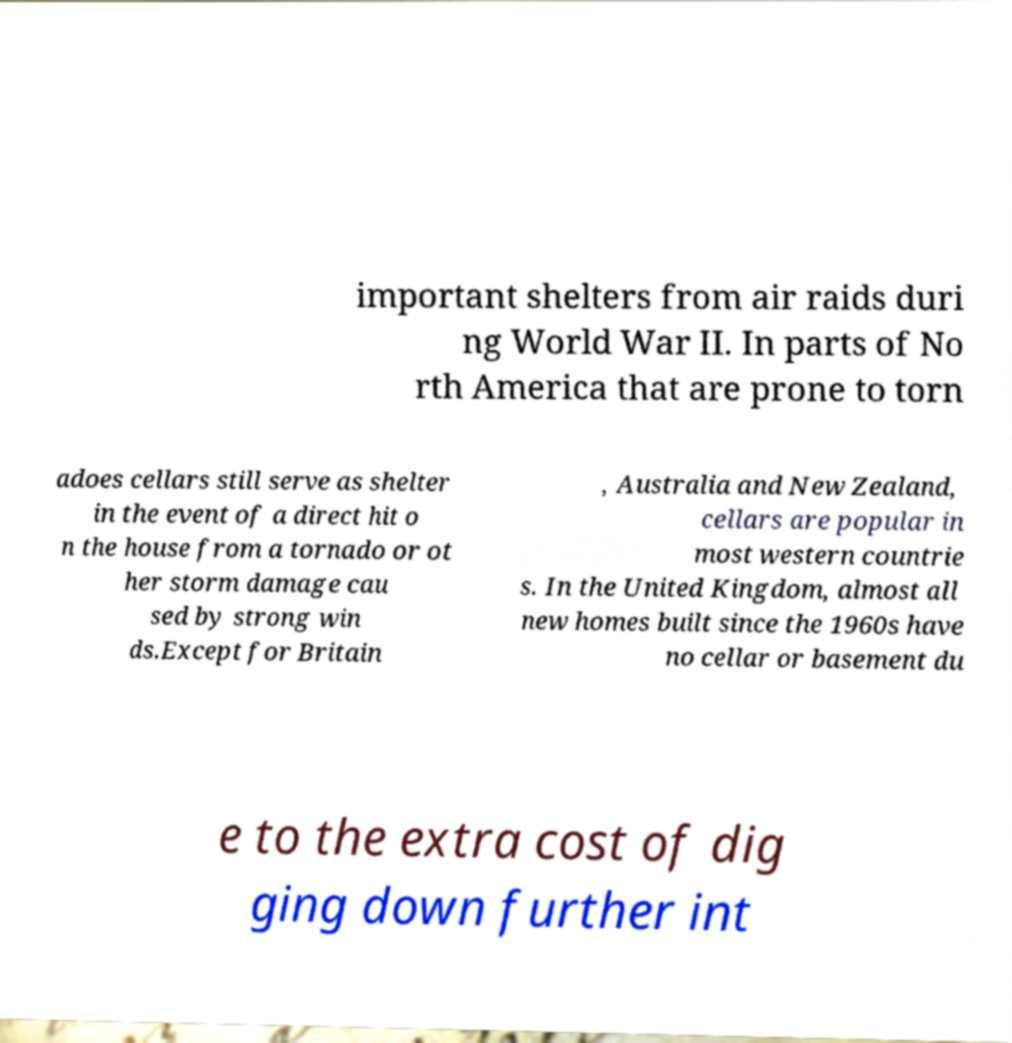What messages or text are displayed in this image? I need them in a readable, typed format. important shelters from air raids duri ng World War II. In parts of No rth America that are prone to torn adoes cellars still serve as shelter in the event of a direct hit o n the house from a tornado or ot her storm damage cau sed by strong win ds.Except for Britain , Australia and New Zealand, cellars are popular in most western countrie s. In the United Kingdom, almost all new homes built since the 1960s have no cellar or basement du e to the extra cost of dig ging down further int 